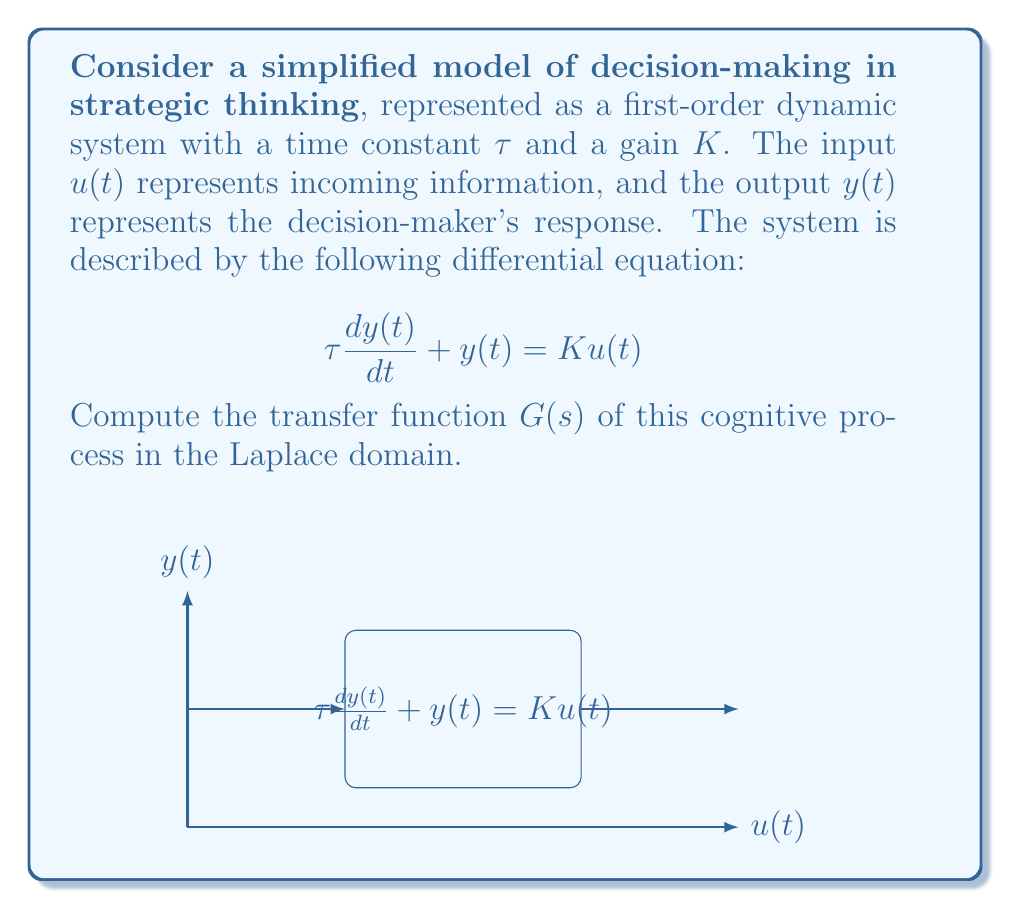Could you help me with this problem? To find the transfer function, we need to follow these steps:

1) First, let's take the Laplace transform of both sides of the differential equation:
   $$\mathcal{L}\{\tau \frac{dy(t)}{dt} + y(t) = Ku(t)\}$$

2) Using the linearity property and the derivative property of the Laplace transform:
   $$\tau [sY(s) - y(0)] + Y(s) = KU(s)$$

3) Assuming zero initial conditions (y(0) = 0):
   $$\tau sY(s) + Y(s) = KU(s)$$

4) Factor out Y(s):
   $$Y(s)(\tau s + 1) = KU(s)$$

5) Divide both sides by U(s) to get the transfer function G(s) = Y(s)/U(s):
   $$G(s) = \frac{Y(s)}{U(s)} = \frac{K}{\tau s + 1}$$

This is the standard form of a first-order transfer function, where K is the steady-state gain and $\tau$ is the time constant of the system.
Answer: $$G(s) = \frac{K}{\tau s + 1}$$ 